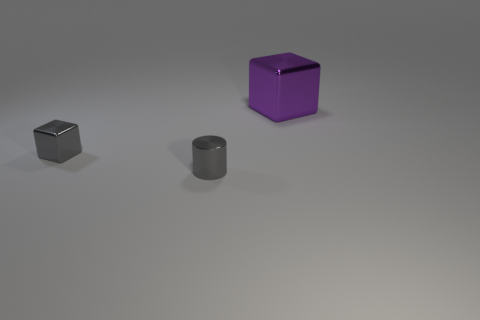Add 3 gray things. How many objects exist? 6 Subtract all cubes. How many objects are left? 1 Subtract 0 yellow spheres. How many objects are left? 3 Subtract all gray shiny things. Subtract all tiny metallic blocks. How many objects are left? 0 Add 1 small metallic cylinders. How many small metallic cylinders are left? 2 Add 1 big blue metal spheres. How many big blue metal spheres exist? 1 